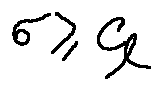<formula> <loc_0><loc_0><loc_500><loc_500>\sigma \geq C _ { l }</formula> 